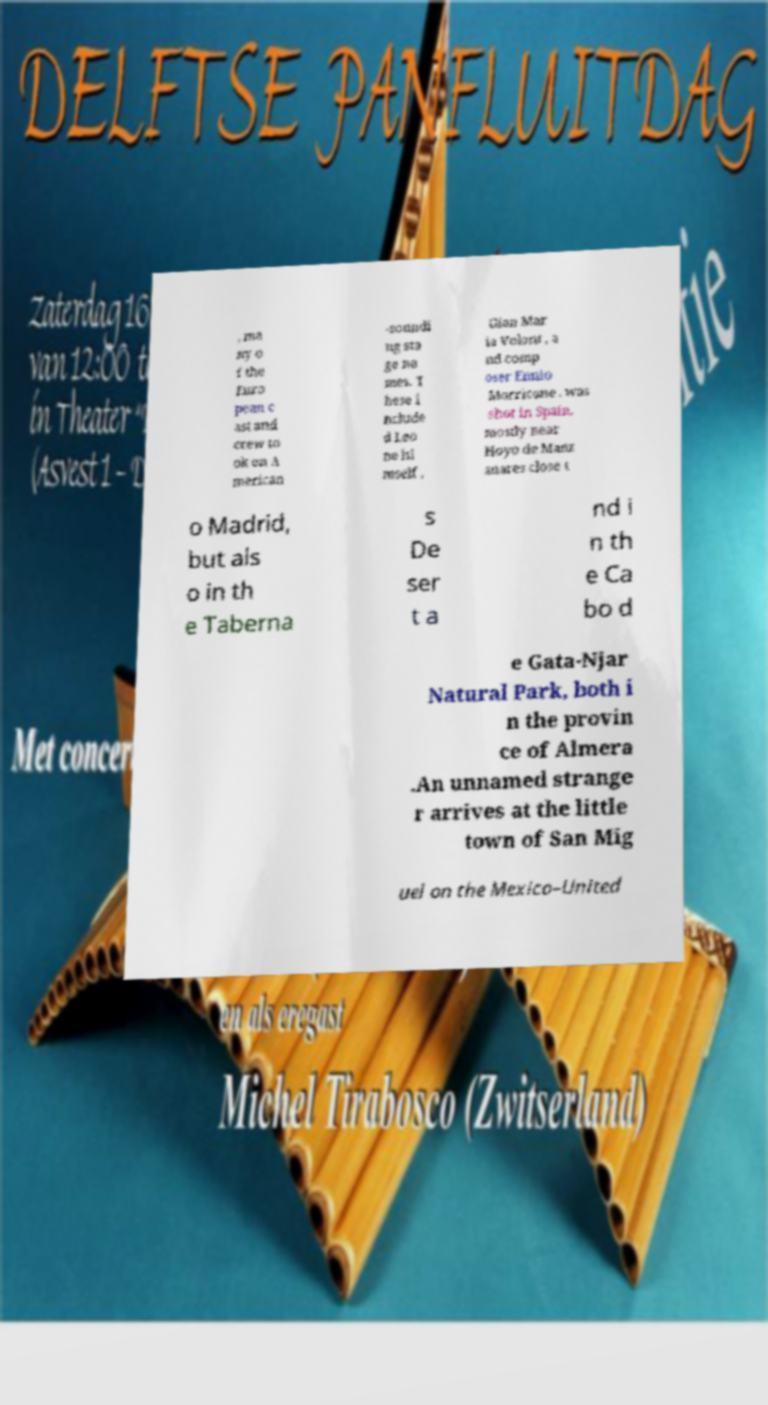What messages or text are displayed in this image? I need them in a readable, typed format. , ma ny o f the Euro pean c ast and crew to ok on A merican -soundi ng sta ge na mes. T hese i nclude d Leo ne hi mself , Gian Mar ia Volont , a nd comp oser Ennio Morricone . was shot in Spain, mostly near Hoyo de Manz anares close t o Madrid, but als o in th e Taberna s De ser t a nd i n th e Ca bo d e Gata-Njar Natural Park, both i n the provin ce of Almera .An unnamed strange r arrives at the little town of San Mig uel on the Mexico–United 